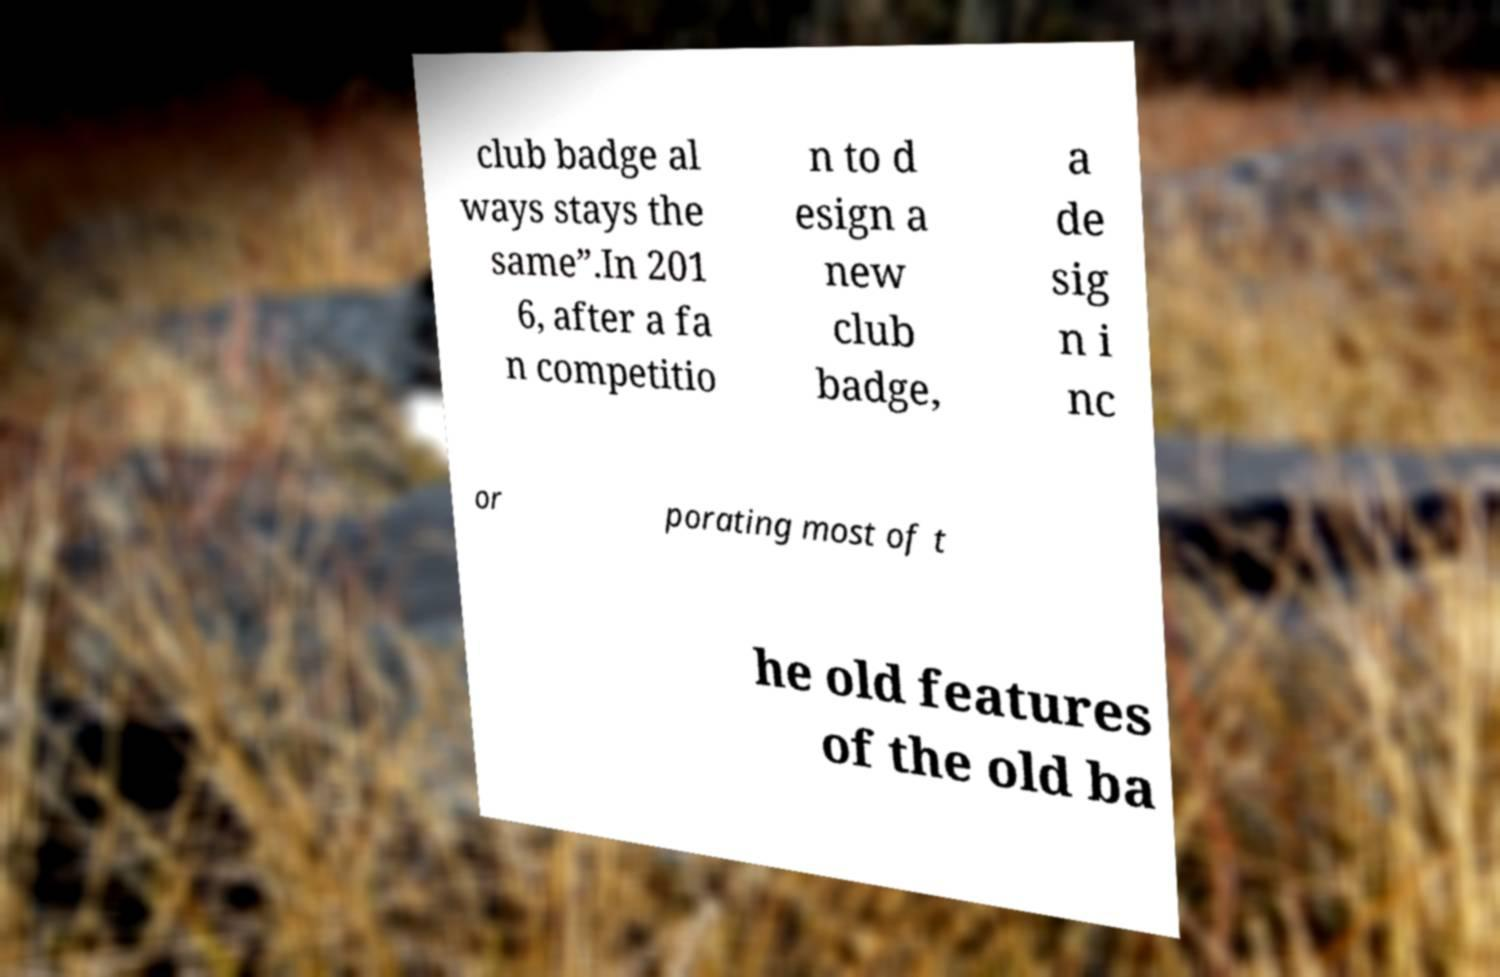Please identify and transcribe the text found in this image. club badge al ways stays the same”.In 201 6, after a fa n competitio n to d esign a new club badge, a de sig n i nc or porating most of t he old features of the old ba 